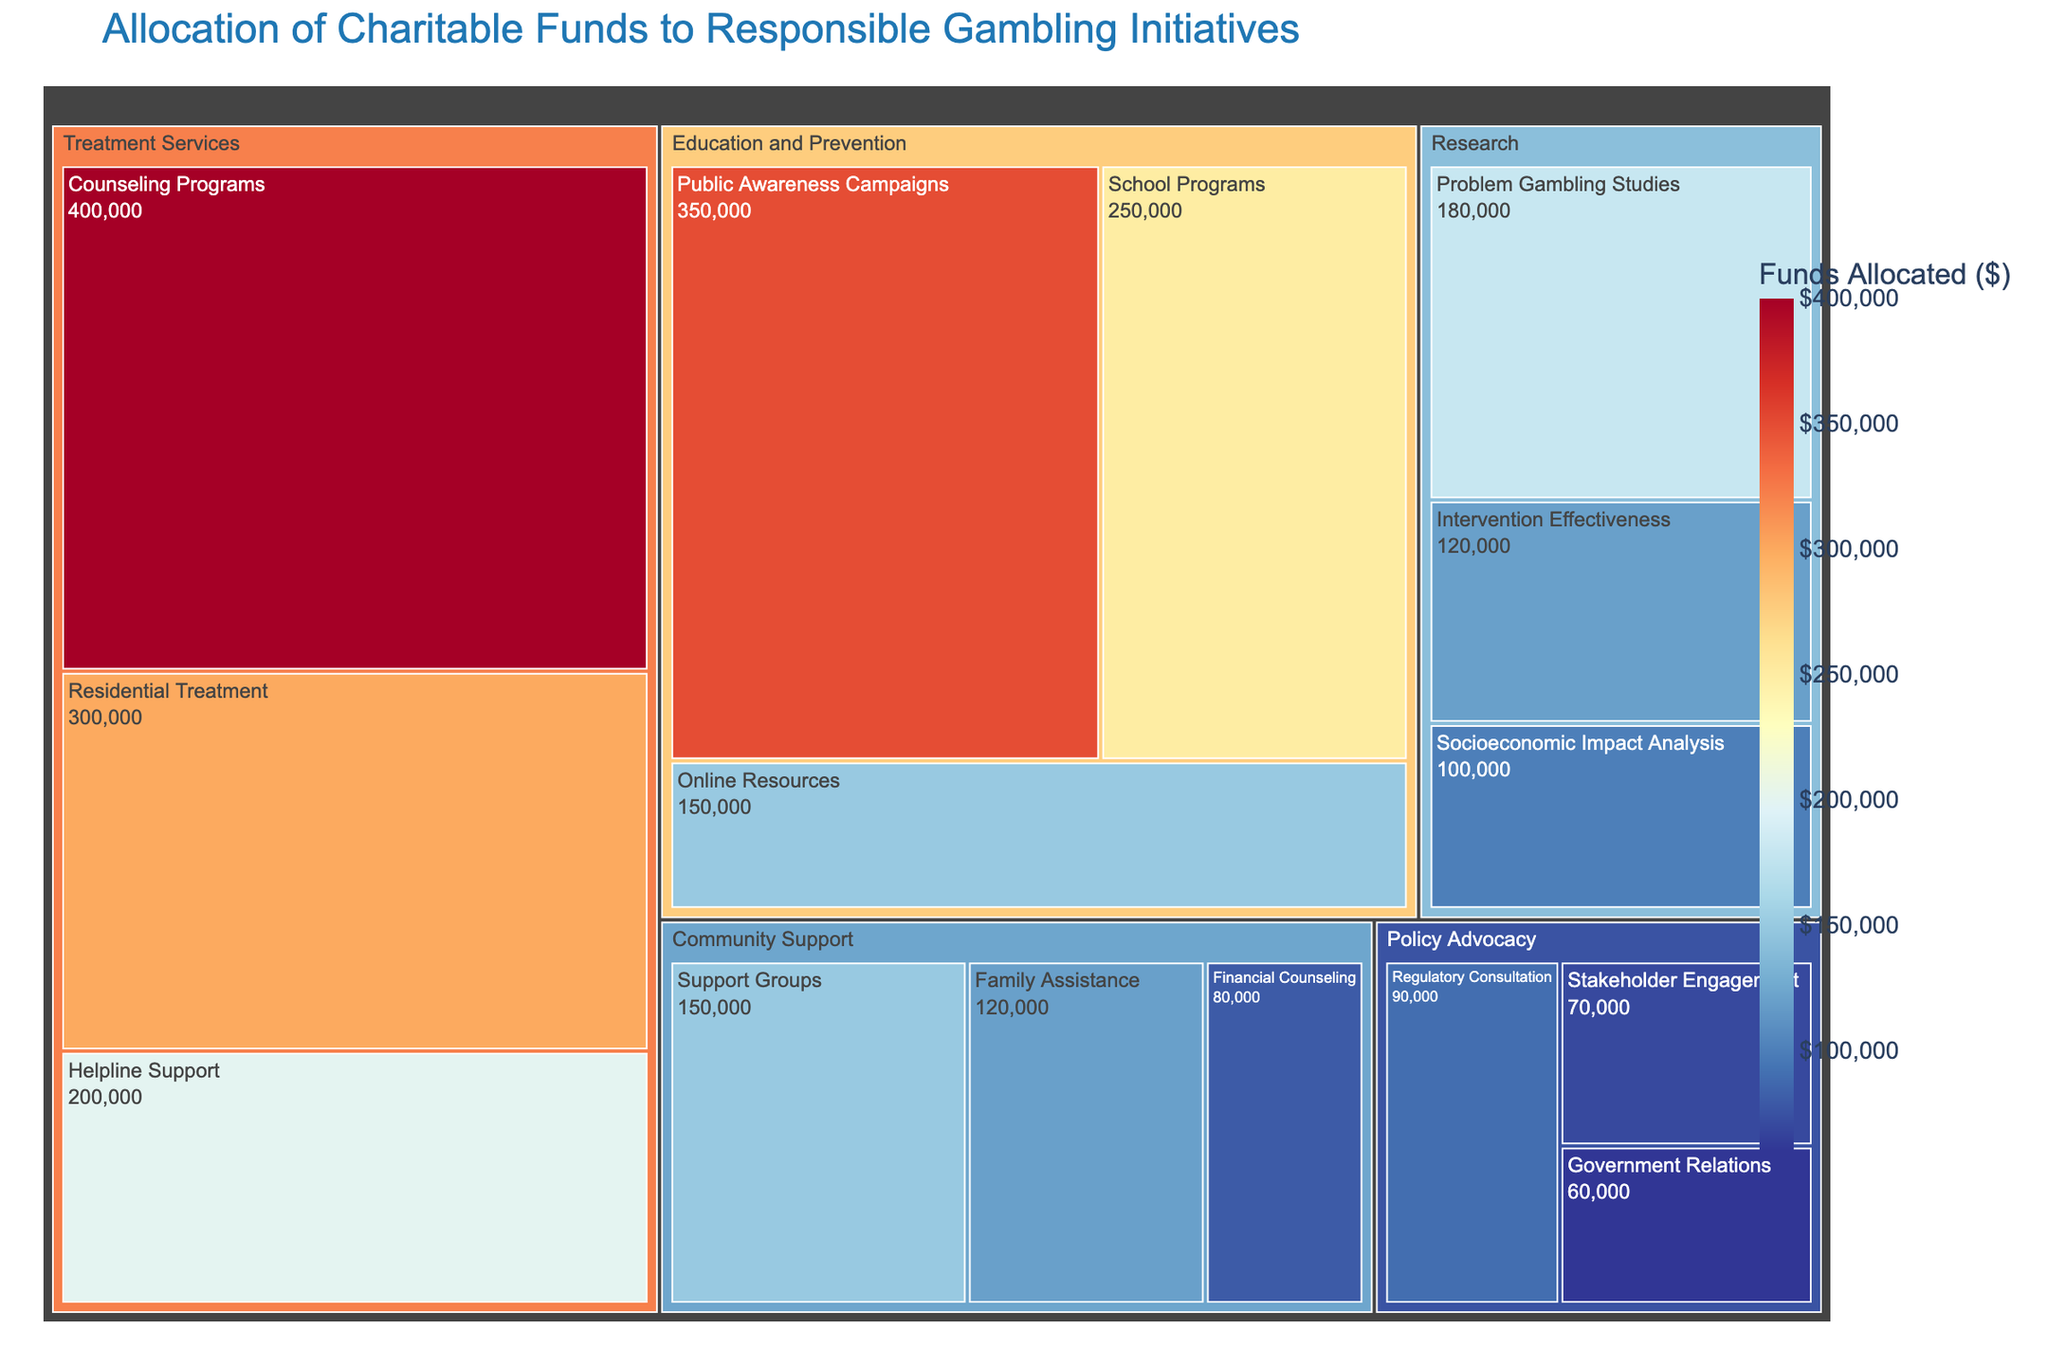What is the title of the Treemap? The title of the Treemap is prominently displayed at the top of the figure. It provides an overview of what the Treemap represents.
Answer: Allocation of Charitable Funds to Responsible Gambling Initiatives Which initiative within the "Education and Prevention" category received the most funds? Look at the subcategories listed under "Education and Prevention" and identify the one with the highest value.
Answer: Public Awareness Campaigns ($350,000) What is the total amount of funds allocated to "Treatment Services"? Sum up the values of all the subcategories under the "Treatment Services" category. The subcategories are Counseling Programs, Helpline Support, and Residential Treatment.
Answer: $900,000 Which subcategory within "Policy Advocacy" has the lowest funding? Identify the subcategories under "Policy Advocacy" and compare their values to determine the lowest one.
Answer: Government Relations ($60,000) How much more funding does "Counseling Programs" receive compared to "Residential Treatment"? Find the values for Counseling Programs and Residential Treatment, then subtract the value of Residential Treatment from Counseling Programs. Counseling Programs received $400,000, and Residential Treatment received $300,000.
Answer: $100,000 What percentage of the total funds is allocated to "Public Awareness Campaigns"? First, find the total sum of all categories. Then, divide the value for Public Awareness Campaigns by this total and multiply by 100 to get the percentage. Public Awareness Campaigns received $350,000.
Answer: 17.5% Which category received the smallest total allocation, and what is the amount? Sum the values of all subcategories within each category and identify the category with the smallest total.
Answer: Policy Advocacy ($220,000) Within the "Community Support" category, which subcategory has the highest value, and what is it? Examine the subcategories listed under "Community Support" and look for the highest value.
Answer: Support Groups ($150,000) Compare the total funding of "Research" to "Community Support". Which category received more, and by how much? Sum the values of all subcategories under "Research" and "Community Support", then compare the two sums. The values for Research are $180,000 + $120,000 + $100,000 = $400,000 and for Community Support are $150,000 + $120,000 + $80,000 = $350,000.
Answer: Research received $50,000 more What is the total amount of funding allocated to "Education and Prevention"? Add the funds allocated to each subcategory within "Education and Prevention". The subcategories are School Programs ($250,000), Public Awareness Campaigns ($350,000), and Online Resources ($150,000).
Answer: $750,000 